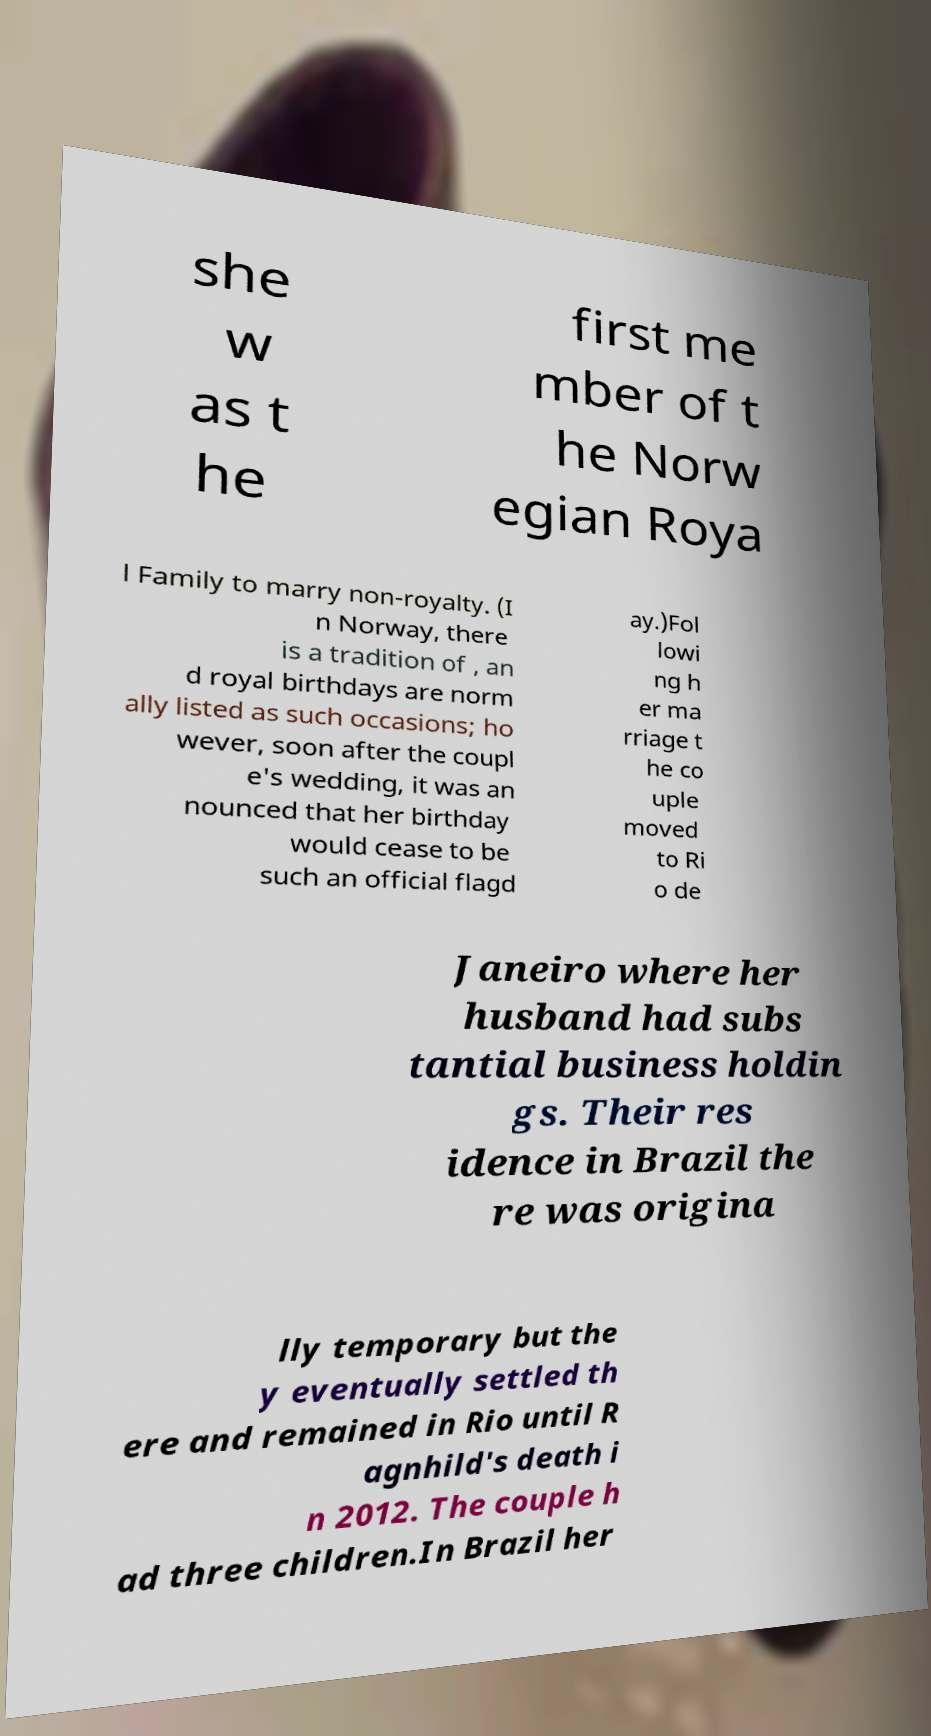I need the written content from this picture converted into text. Can you do that? she w as t he first me mber of t he Norw egian Roya l Family to marry non-royalty. (I n Norway, there is a tradition of , an d royal birthdays are norm ally listed as such occasions; ho wever, soon after the coupl e's wedding, it was an nounced that her birthday would cease to be such an official flagd ay.)Fol lowi ng h er ma rriage t he co uple moved to Ri o de Janeiro where her husband had subs tantial business holdin gs. Their res idence in Brazil the re was origina lly temporary but the y eventually settled th ere and remained in Rio until R agnhild's death i n 2012. The couple h ad three children.In Brazil her 